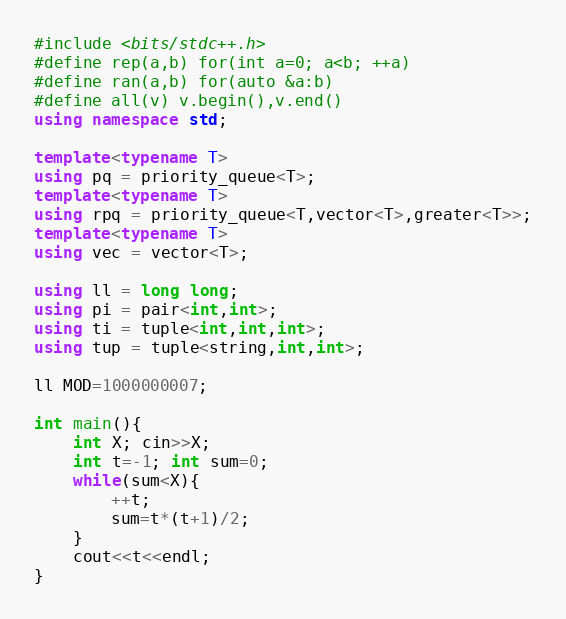Convert code to text. <code><loc_0><loc_0><loc_500><loc_500><_C++_>#include <bits/stdc++.h>
#define rep(a,b) for(int a=0; a<b; ++a)
#define ran(a,b) for(auto &a:b)
#define all(v) v.begin(),v.end()
using namespace std;

template<typename T>
using pq = priority_queue<T>;
template<typename T>
using rpq = priority_queue<T,vector<T>,greater<T>>;
template<typename T>
using vec = vector<T>;

using ll = long long;
using pi = pair<int,int>;
using ti = tuple<int,int,int>;
using tup = tuple<string,int,int>;

ll MOD=1000000007;

int main(){
	int X; cin>>X;
	int t=-1; int sum=0;
	while(sum<X){
		++t;
		sum=t*(t+1)/2;
	}
	cout<<t<<endl;
}</code> 